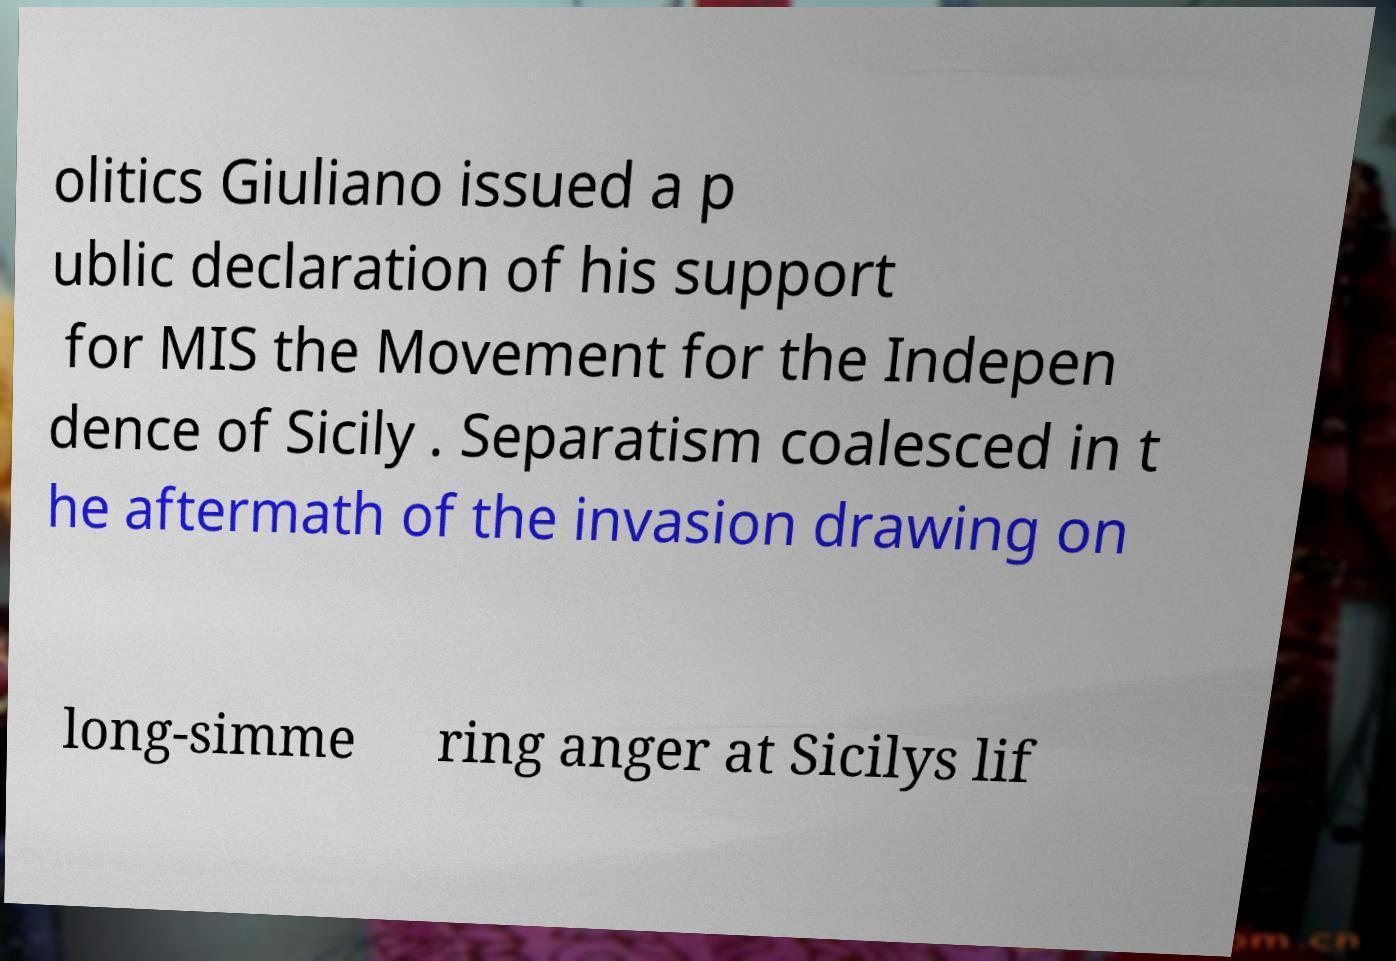Please identify and transcribe the text found in this image. olitics Giuliano issued a p ublic declaration of his support for MIS the Movement for the Indepen dence of Sicily . Separatism coalesced in t he aftermath of the invasion drawing on long-simme ring anger at Sicilys lif 